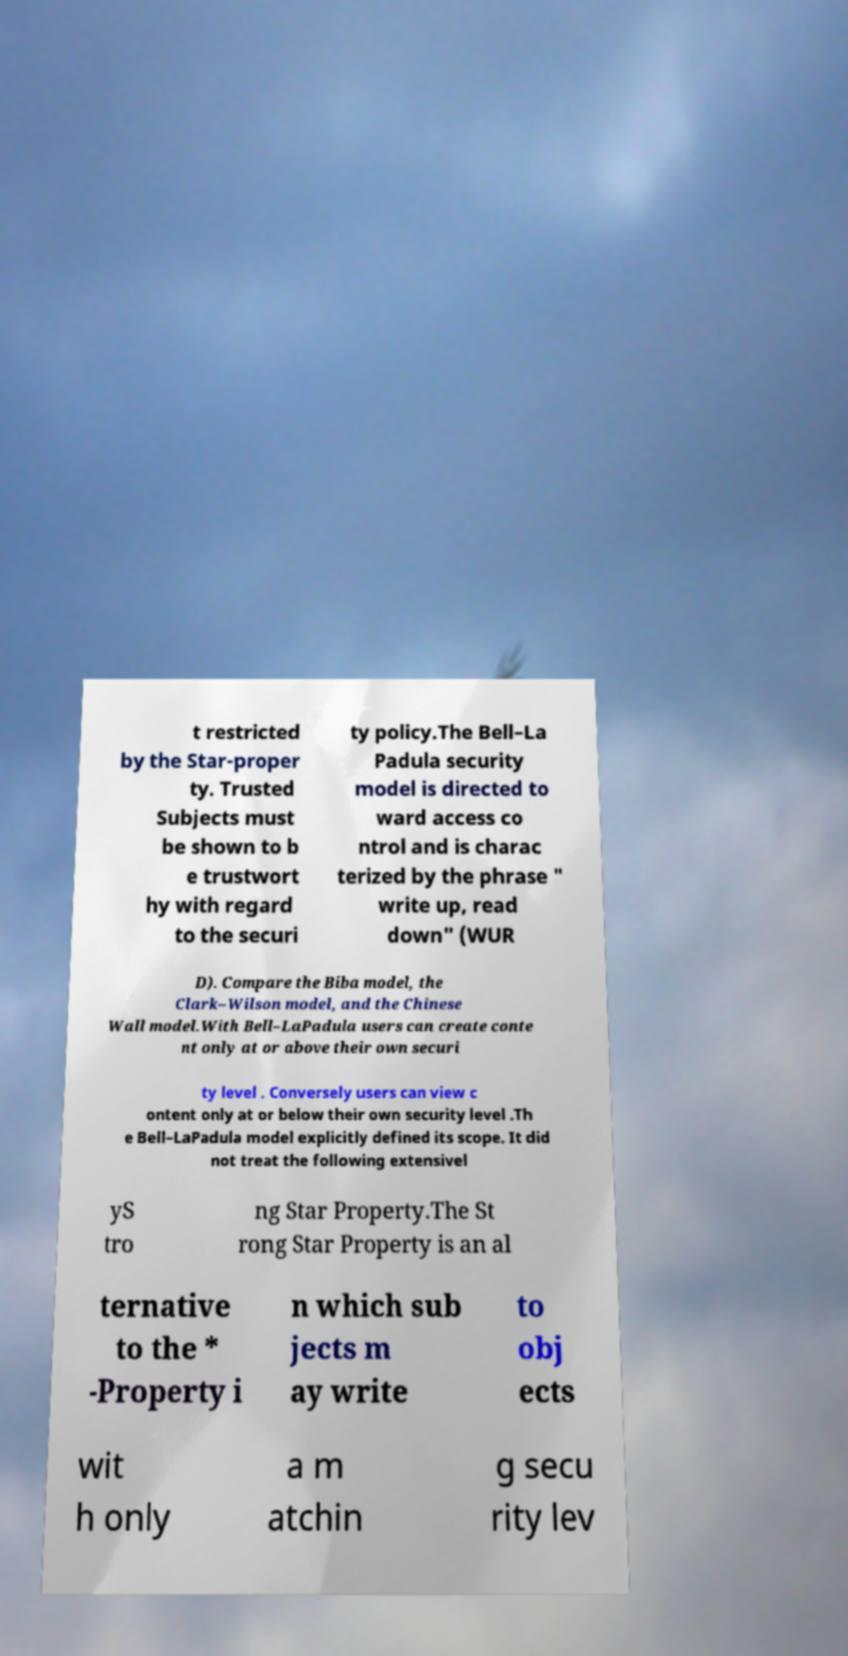I need the written content from this picture converted into text. Can you do that? t restricted by the Star-proper ty. Trusted Subjects must be shown to b e trustwort hy with regard to the securi ty policy.The Bell–La Padula security model is directed to ward access co ntrol and is charac terized by the phrase " write up, read down" (WUR D). Compare the Biba model, the Clark–Wilson model, and the Chinese Wall model.With Bell–LaPadula users can create conte nt only at or above their own securi ty level . Conversely users can view c ontent only at or below their own security level .Th e Bell–LaPadula model explicitly defined its scope. It did not treat the following extensivel yS tro ng Star Property.The St rong Star Property is an al ternative to the * -Property i n which sub jects m ay write to obj ects wit h only a m atchin g secu rity lev 